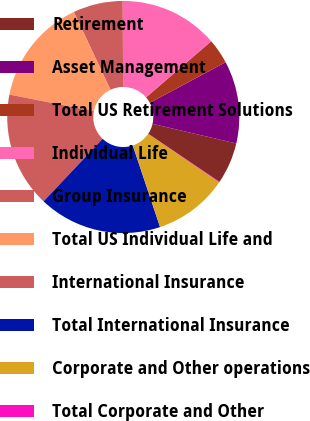Convert chart. <chart><loc_0><loc_0><loc_500><loc_500><pie_chart><fcel>Retirement<fcel>Asset Management<fcel>Total US Retirement Solutions<fcel>Individual Life<fcel>Group Insurance<fcel>Total US Individual Life and<fcel>International Insurance<fcel>Total International Insurance<fcel>Corporate and Other operations<fcel>Total Corporate and Other<nl><fcel>5.78%<fcel>11.48%<fcel>3.5%<fcel>13.76%<fcel>6.92%<fcel>14.9%<fcel>16.04%<fcel>17.18%<fcel>10.34%<fcel>0.08%<nl></chart> 